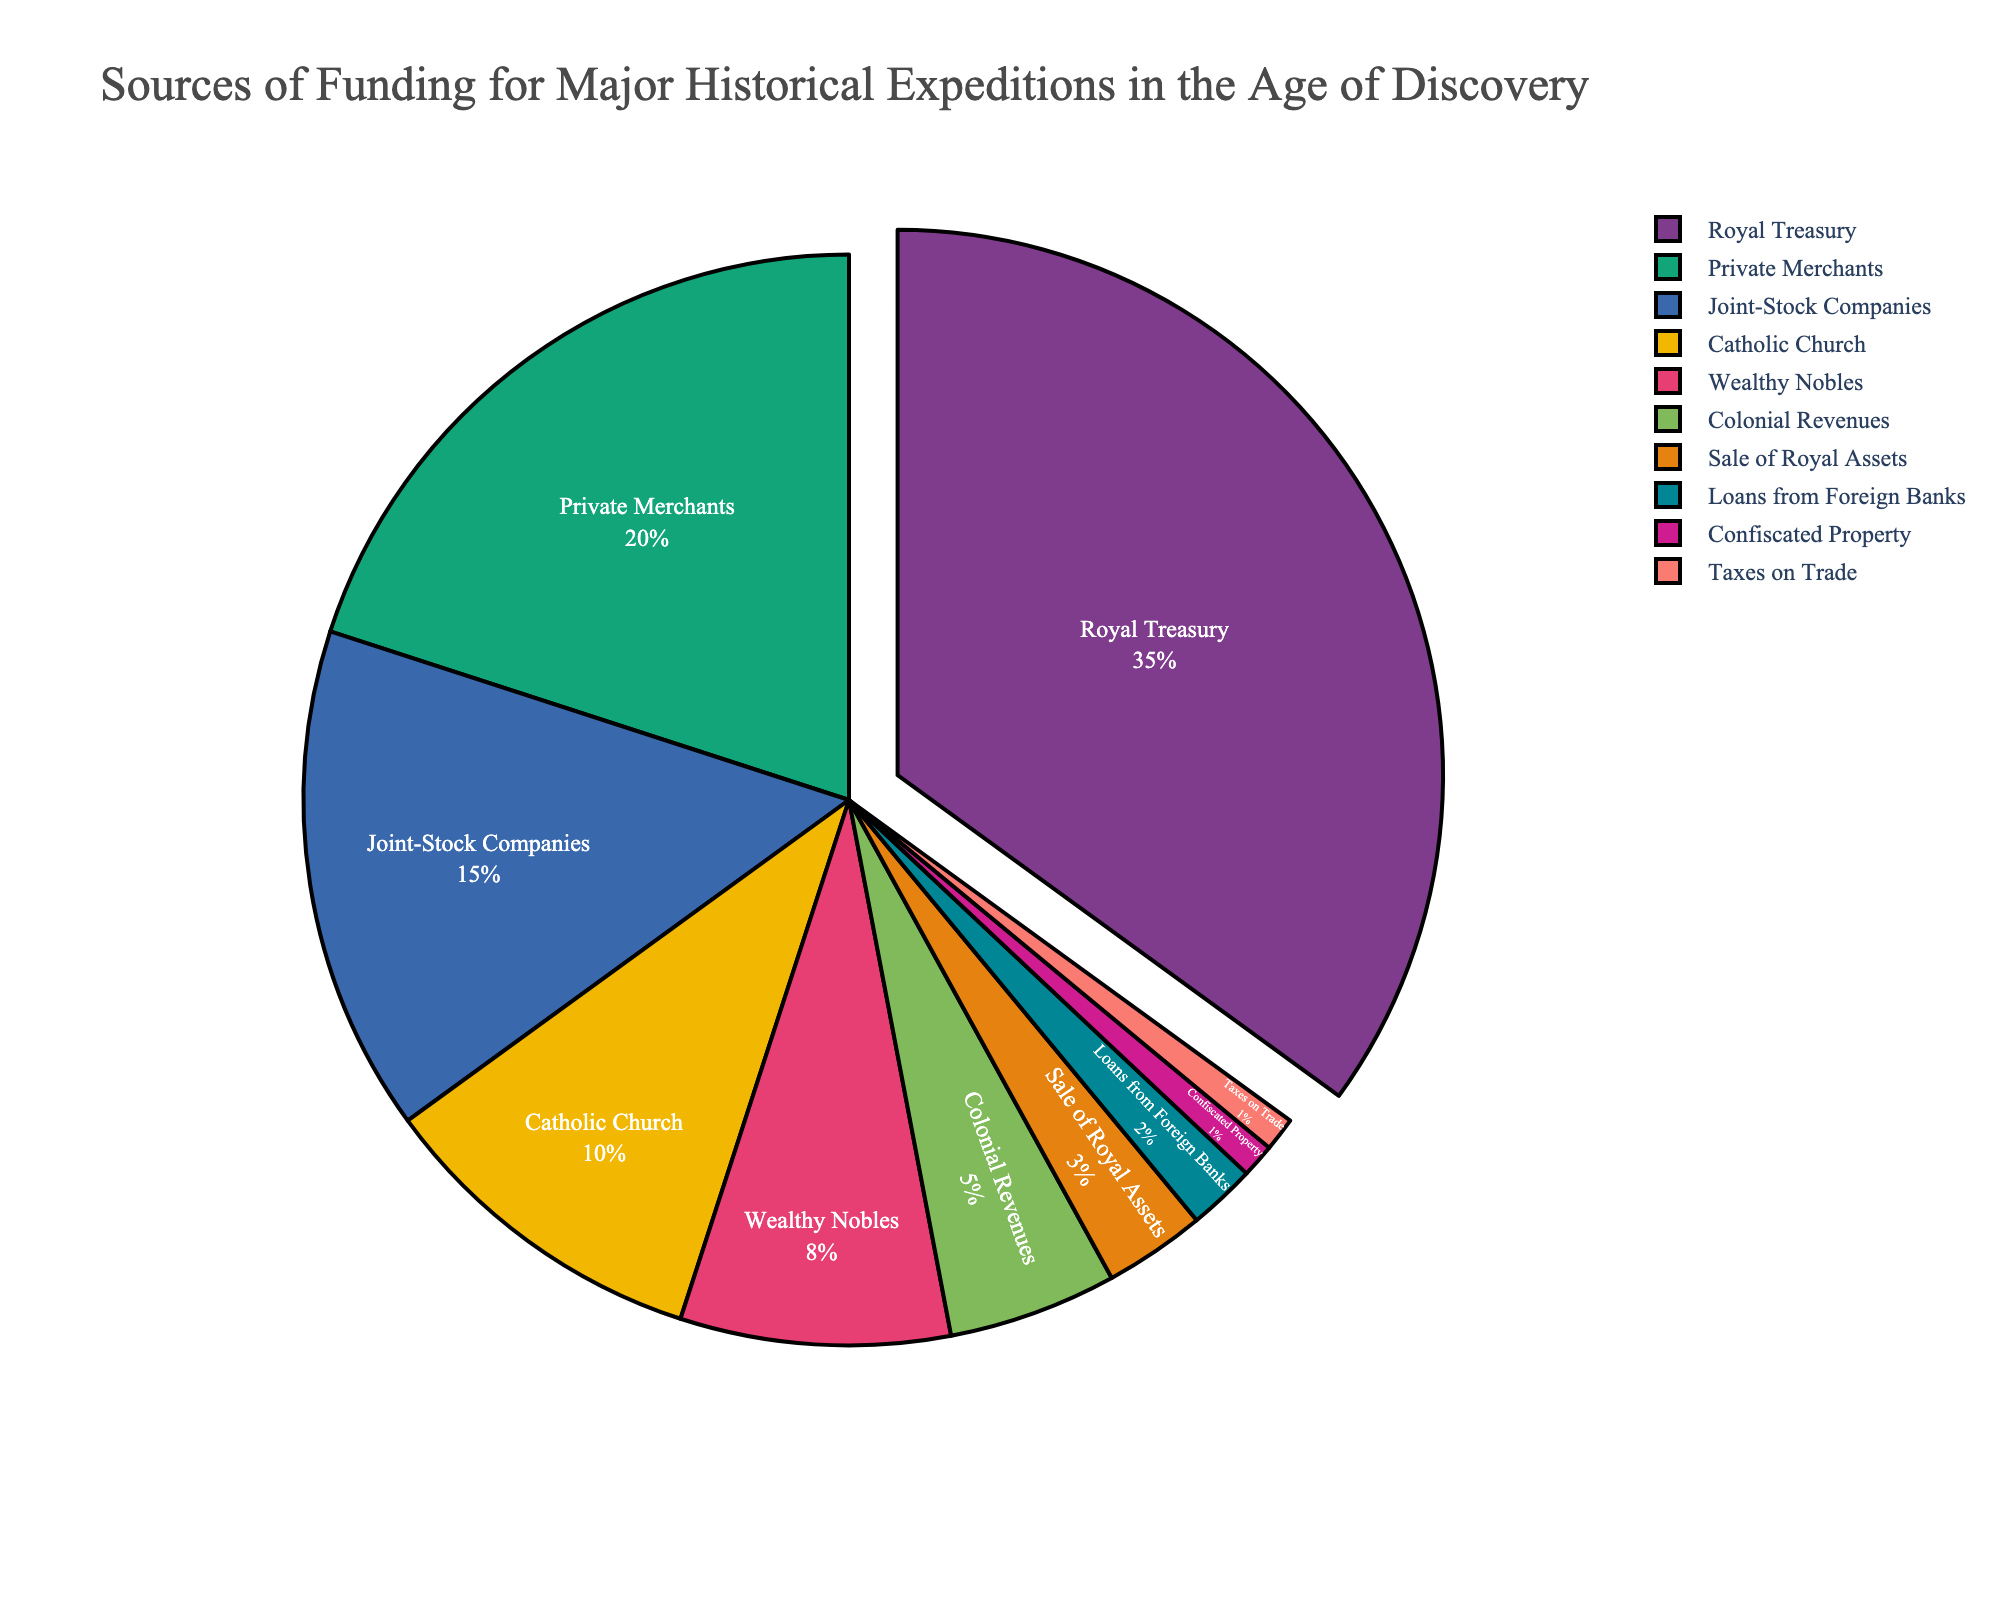Which source of funding contributes the most to major historical expeditions in the Age of Discovery? The pie chart visually shows that the largest segment, pulled out slightly, represents the Royal Treasury with 35%.
Answer: Royal Treasury Which source of funding accounts for the smallest share? The smallest segment in the pie chart corresponds to Confiscated Property and Taxes on Trade, each contributing 1%.
Answer: Confiscated Property and Taxes on Trade How much more funding does the Royal Treasury provide compared to Private Merchants? The Royal Treasury provides 35%, and Private Merchants provide 20%. The difference is 35% - 20%.
Answer: 15% How does the combined contribution of Private Merchants and Joint-Stock Companies compare to the Royal Treasury's contribution? Private Merchants provide 20% and Joint-Stock Companies provide 15%. Together, they contribute 20% + 15% = 35%, which is equal to the Royal Treasury's 35%.
Answer: Equal What proportion of the total funding comes from the top three sources? The top three sources are Royal Treasury (35%), Private Merchants (20%), and Joint-Stock Companies (15%). Adding these gives 35% + 20% + 15% = 70%.
Answer: 70% What is the difference in funding between the Catholic Church and Colonial Revenues? The Catholic Church contributes 10%, while Colonial Revenues contribute 5%. The difference is 10% - 5%.
Answer: 5% Which funding source has twice the contribution of Colonial Revenues? Colonial Revenues contribute 5%. The Catholic Church contributes twice that amount, which is 10%.
Answer: Catholic Church What is the total percentage of funding provided by the Wealthy Nobles, Sales of Royal Assets, and Loans from Foreign Banks combined? Wealthy Nobles contribute 8%, Sale of Royal Assets 3%, and Loans from Foreign Banks 2%. Combined, they total 8% + 3% + 2% = 13%.
Answer: 13% Which sources contribute less than 5% each? According to the pie chart, Sale of Royal Assets (3%), Loans from Foreign Banks (2%), Confiscated Property (1%), and Taxes on Trade (1%) each contribute less than 5%.
Answer: Sale of Royal Assets, Loans from Foreign Banks, Confiscated Property, Taxes on Trade 